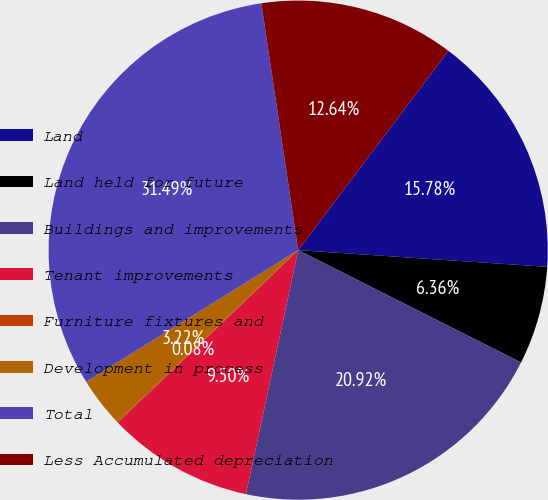Convert chart to OTSL. <chart><loc_0><loc_0><loc_500><loc_500><pie_chart><fcel>Land<fcel>Land held for future<fcel>Buildings and improvements<fcel>Tenant improvements<fcel>Furniture fixtures and<fcel>Development in process<fcel>Total<fcel>Less Accumulated depreciation<nl><fcel>15.78%<fcel>6.36%<fcel>20.92%<fcel>9.5%<fcel>0.08%<fcel>3.22%<fcel>31.48%<fcel>12.64%<nl></chart> 